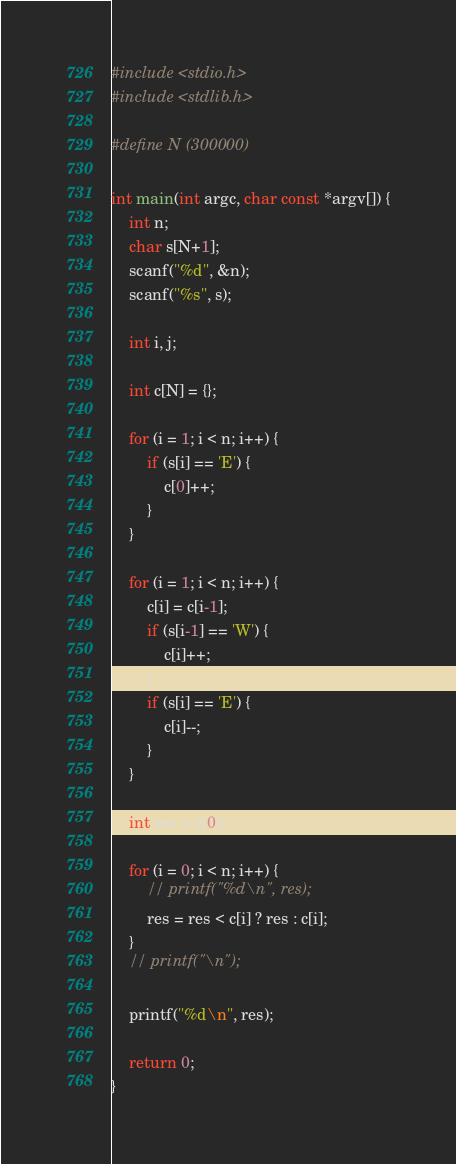<code> <loc_0><loc_0><loc_500><loc_500><_C_>#include <stdio.h>
#include <stdlib.h>

#define N (300000)

int main(int argc, char const *argv[]) {
	int n;
	char s[N+1];
	scanf("%d", &n);
	scanf("%s", s);

	int i, j;

	int c[N] = {};

	for (i = 1; i < n; i++) {
		if (s[i] == 'E') {
			c[0]++;
		}
	}

	for (i = 1; i < n; i++) {
		c[i] = c[i-1];
		if (s[i-1] == 'W') {
			c[i]++;
		}
		if (s[i] == 'E') {
			c[i]--;
		}
	}

	int res = c[0];

	for (i = 0; i < n; i++) {
		// printf("%d\n", res);
		res = res < c[i] ? res : c[i];
	}
	// printf("\n");

	printf("%d\n", res);

	return 0;
}
</code> 